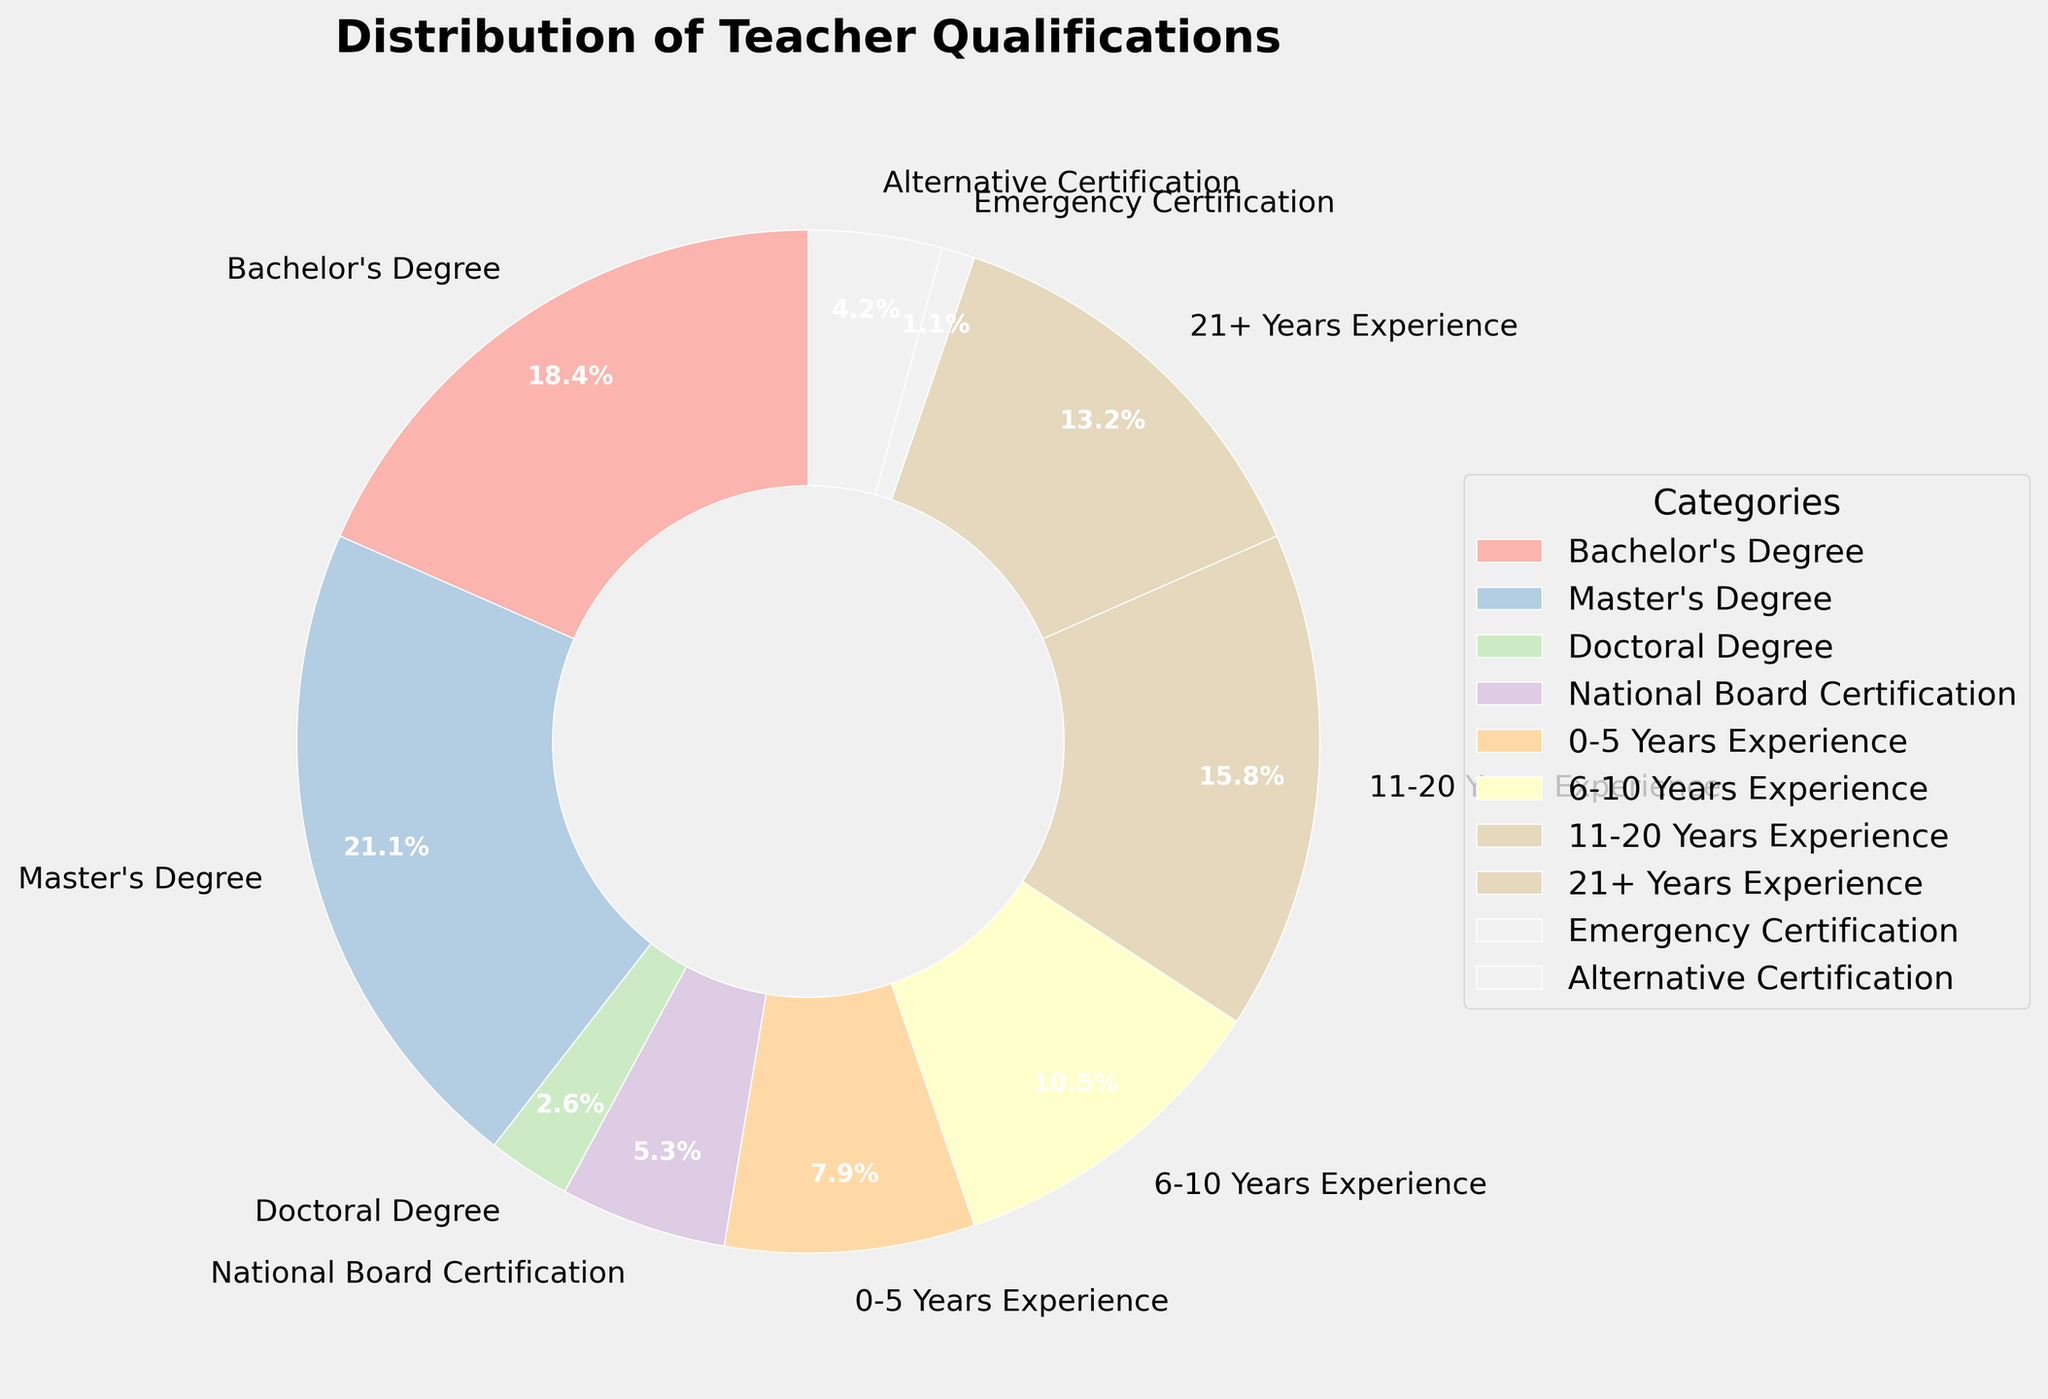What's the largest percentage category for teacher qualifications? By observing the figure, we can see that "Master's Degree" occupies the largest portion of the pie chart.
Answer: Master's Degree What is the combined percentage of teachers with Bachelor's and Master's Degrees? From the figure, we see that Bachelor's Degree is 35% and Master's Degree is 40%. Adding these two gives us 35% + 40% = 75%.
Answer: 75% Which experience group has more teachers, 11-20 Years Experience or 21+ Years Experience? We observe that 11-20 Years Experience is represented as 30% and 21+ Years Experience as 25%. Therefore, 11-20 Years Experience has more teachers.
Answer: 11-20 Years Experience Which category has the smallest percentage and what is it? The segment with the smallest slice in the pie chart belongs to "Emergency Certification" at 2%.
Answer: Emergency Certification How much more percentage do teachers with National Board Certification have compared to those with Doctoral Degrees? National Board Certification is 10% and Doctoral Degrees are 5%. The difference is 10% - 5% = 5%.
Answer: 5% What is the combined percentage of teachers with an Alternative Certification and Emergency Certification? According to the chart, Alternative Certification is 8% and Emergency Certification is 2%. Combined, the total is 8% + 2% = 10%.
Answer: 10% Are there more teachers with 0-5 Years Experience or 6-10 Years Experience and by how much? The chart shows that 0-5 Years Experience is 15% and 6-10 Years Experience is 20%. The difference is 20% - 15% = 5%, with 6-10 Years Experience being more.
Answer: 6-10 Years Experience by 5% What is the difference in percentage between teachers having a Master’s Degree and teachers with an Alternative Certification? Teachers with a Master's Degree comprise 40% of the chart, while those with an Alternative Certification account for 8%. The difference is 40% - 8% = 32%.
Answer: 32% 